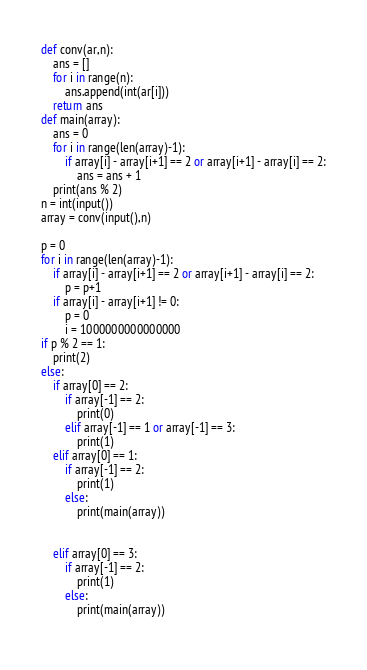<code> <loc_0><loc_0><loc_500><loc_500><_Python_>def conv(ar,n):
    ans = []
    for i in range(n):
        ans.append(int(ar[i]))
    return ans
def main(array):
    ans = 0
    for i in range(len(array)-1):
        if array[i] - array[i+1] == 2 or array[i+1] - array[i] == 2:
            ans = ans + 1
    print(ans % 2)
n = int(input())
array = conv(input(),n)

p = 0
for i in range(len(array)-1):
    if array[i] - array[i+1] == 2 or array[i+1] - array[i] == 2:
        p = p+1
    if array[i] - array[i+1] != 0:
        p = 0
        i = 1000000000000000
if p % 2 == 1:
    print(2)
else:
    if array[0] == 2:
        if array[-1] == 2:
            print(0)
        elif array[-1] == 1 or array[-1] == 3:
            print(1)
    elif array[0] == 1:
        if array[-1] == 2:
            print(1)
        else:
            print(main(array))
        
        
    elif array[0] == 3:
        if array[-1] == 2:
            print(1)
        else:
            print(main(array))
     </code> 